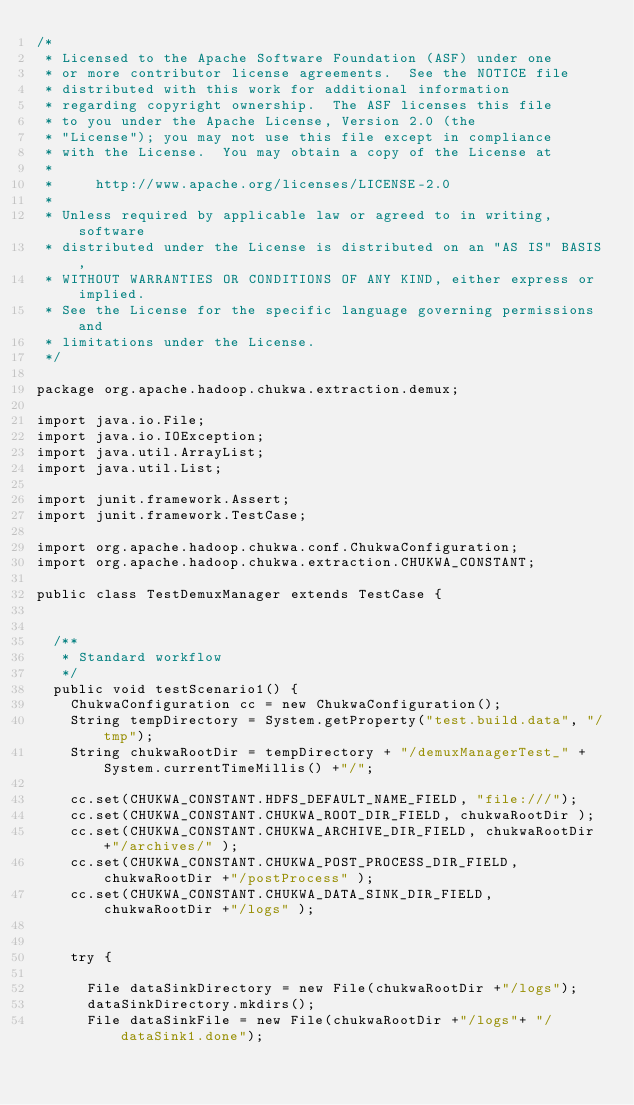Convert code to text. <code><loc_0><loc_0><loc_500><loc_500><_Java_>/*
 * Licensed to the Apache Software Foundation (ASF) under one
 * or more contributor license agreements.  See the NOTICE file
 * distributed with this work for additional information
 * regarding copyright ownership.  The ASF licenses this file
 * to you under the Apache License, Version 2.0 (the
 * "License"); you may not use this file except in compliance
 * with the License.  You may obtain a copy of the License at
 *
 *     http://www.apache.org/licenses/LICENSE-2.0
 *
 * Unless required by applicable law or agreed to in writing, software
 * distributed under the License is distributed on an "AS IS" BASIS,
 * WITHOUT WARRANTIES OR CONDITIONS OF ANY KIND, either express or implied.
 * See the License for the specific language governing permissions and
 * limitations under the License.
 */

package org.apache.hadoop.chukwa.extraction.demux;

import java.io.File;
import java.io.IOException;
import java.util.ArrayList;
import java.util.List;

import junit.framework.Assert;
import junit.framework.TestCase;

import org.apache.hadoop.chukwa.conf.ChukwaConfiguration;
import org.apache.hadoop.chukwa.extraction.CHUKWA_CONSTANT;

public class TestDemuxManager extends TestCase {

  
  /**
   * Standard workflow
   */
  public void testScenario1() {
    ChukwaConfiguration cc = new ChukwaConfiguration();
    String tempDirectory = System.getProperty("test.build.data", "/tmp");
    String chukwaRootDir = tempDirectory + "/demuxManagerTest_" + System.currentTimeMillis() +"/";
    
    cc.set(CHUKWA_CONSTANT.HDFS_DEFAULT_NAME_FIELD, "file:///");
    cc.set(CHUKWA_CONSTANT.CHUKWA_ROOT_DIR_FIELD, chukwaRootDir );
    cc.set(CHUKWA_CONSTANT.CHUKWA_ARCHIVE_DIR_FIELD, chukwaRootDir +"/archives/" );
    cc.set(CHUKWA_CONSTANT.CHUKWA_POST_PROCESS_DIR_FIELD, chukwaRootDir +"/postProcess" );
    cc.set(CHUKWA_CONSTANT.CHUKWA_DATA_SINK_DIR_FIELD, chukwaRootDir +"/logs" );
    
     
    try {
      
      File dataSinkDirectory = new File(chukwaRootDir +"/logs");
      dataSinkDirectory.mkdirs();
      File dataSinkFile = new File(chukwaRootDir +"/logs"+ "/dataSink1.done");</code> 